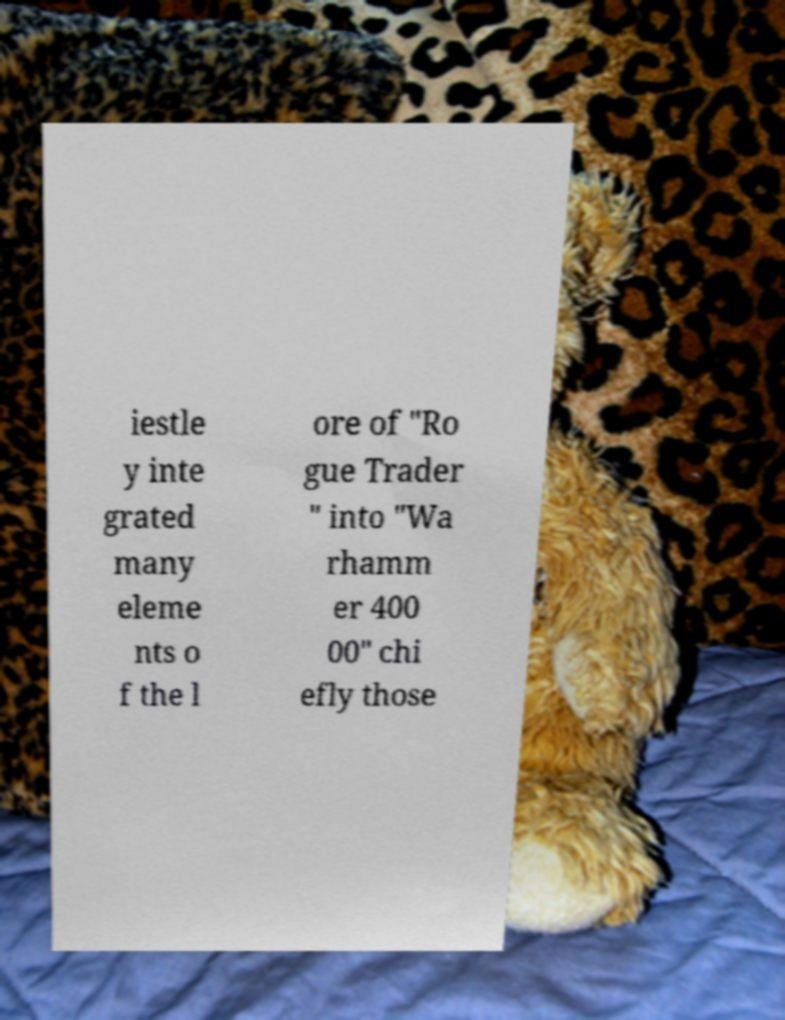Please identify and transcribe the text found in this image. iestle y inte grated many eleme nts o f the l ore of "Ro gue Trader " into "Wa rhamm er 400 00" chi efly those 